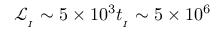<formula> <loc_0><loc_0><loc_500><loc_500>\mathcal { L } _ { _ { I } } \sim 5 \times 1 0 ^ { 3 } t _ { _ { I } } \sim 5 \times 1 0 ^ { 6 }</formula> 